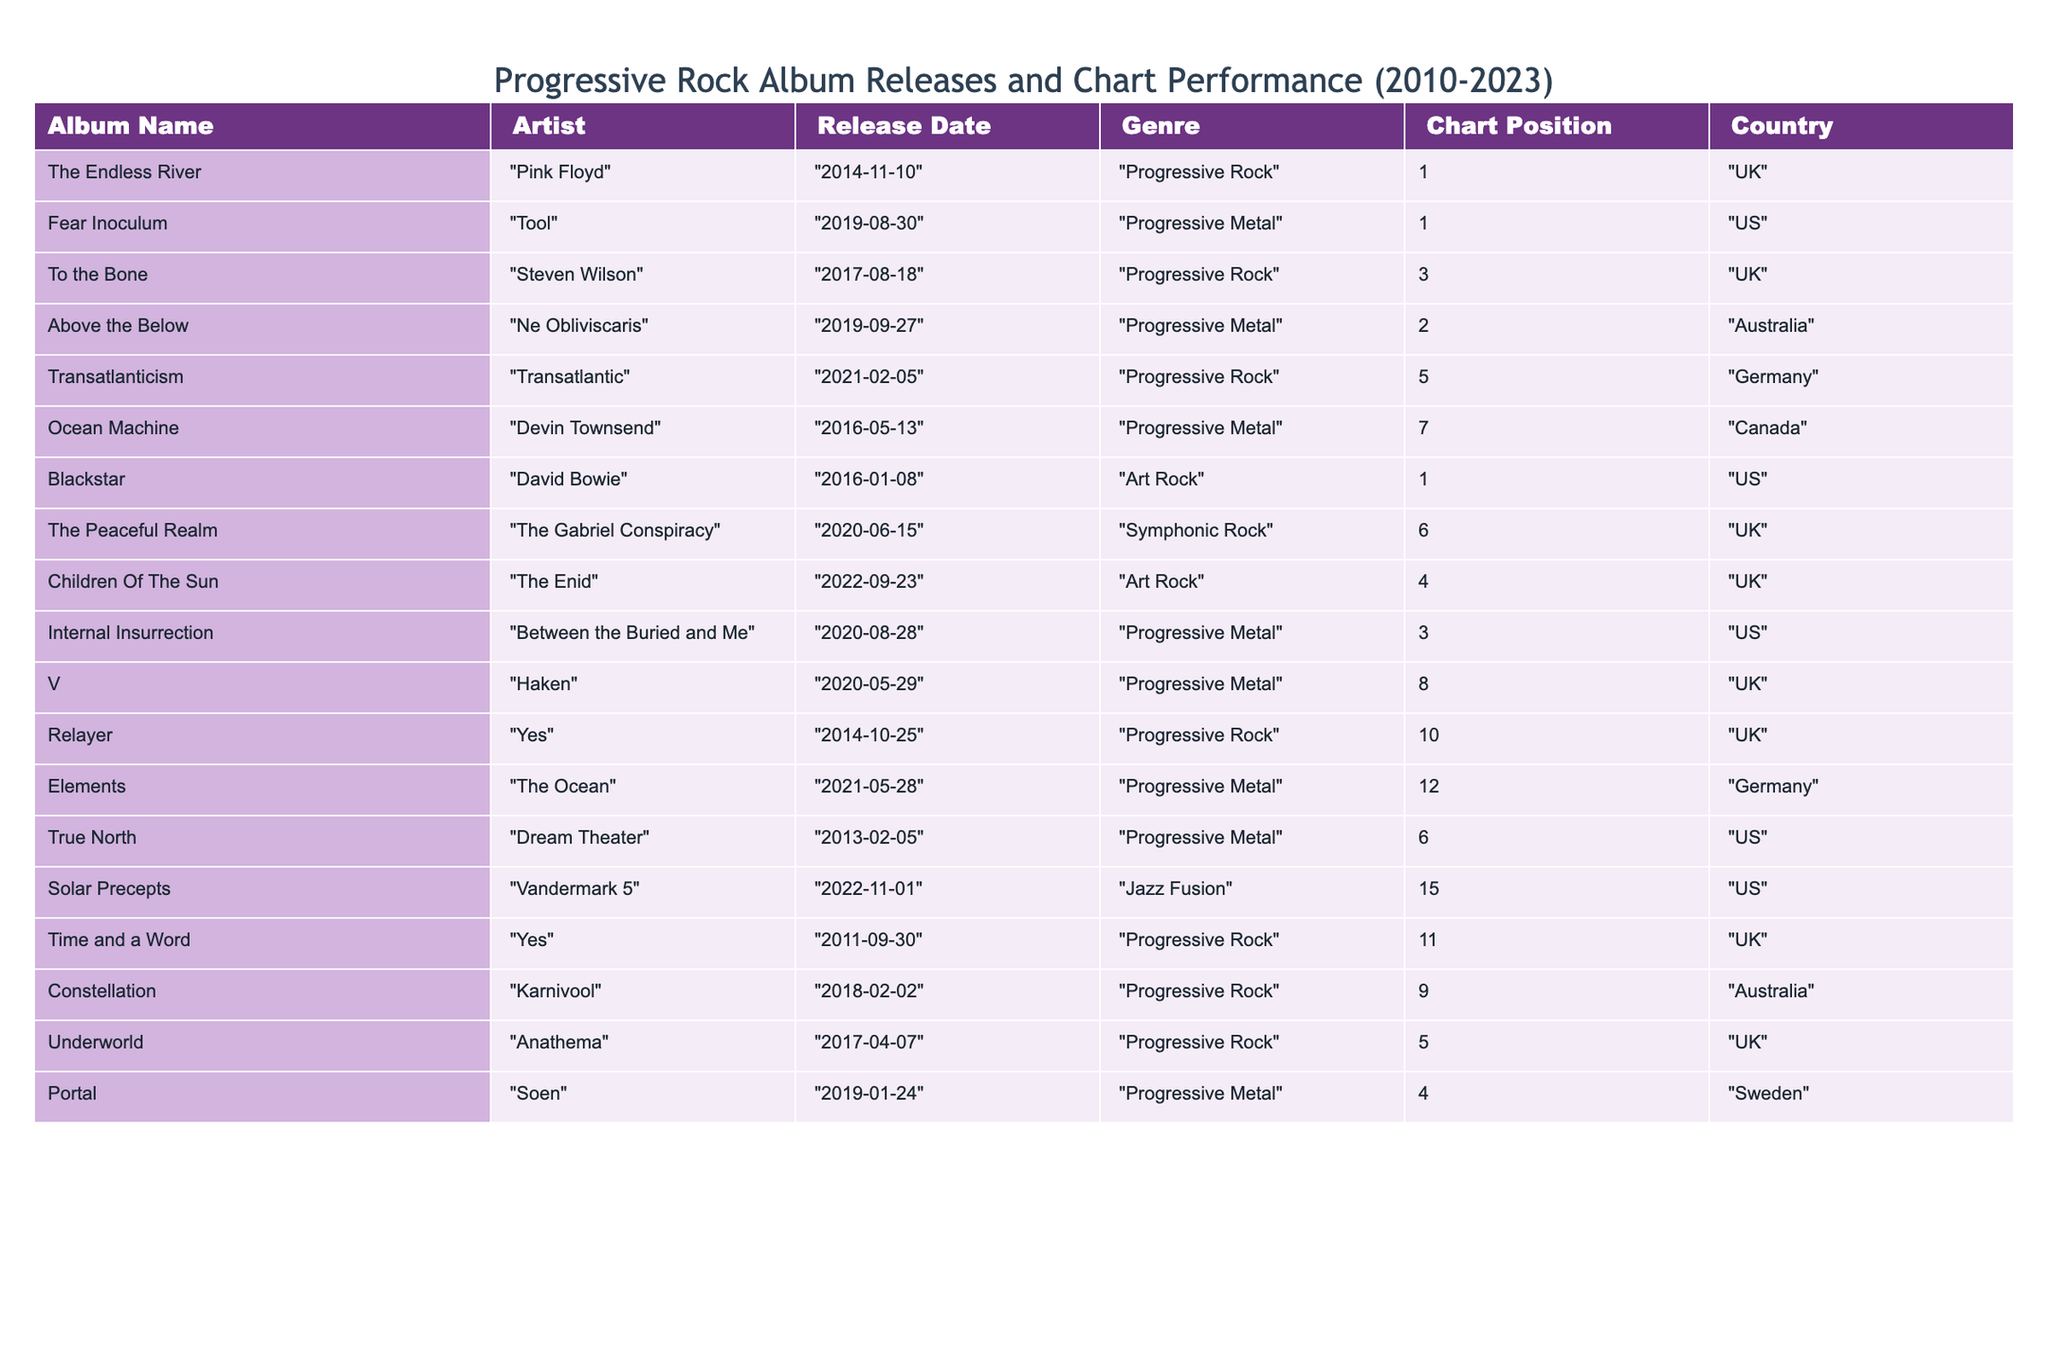What's the highest chart position achieved by a progressive rock album in this table? The table shows the "Chart Position" column for progressive rock albums. Scanning through, I see that "The Endless River" by Pink Floyd achieved a position of 1, which is the highest.
Answer: 1 Which artist released an album with a chart position of 8? By checking the table, "Haken" released the album "V," and it reached a chart position of 8.
Answer: Haken How many albums from the US are listed and what are their chart positions? Looking through the "Country" column, I find three albums from the US: "Fear Inoculum" (1), "Blackstar" (1), and "True North" (6). Summing their chart positions gives us 1 + 1 + 6 = 8.
Answer: 8 Which progressive metal album was released first and what was its chart position? The table lists "True North" by Dream Theater as released on "2013-02-05," which is earlier than the other metal albums. It reached chart position 6.
Answer: True North, 6 What is the average chart position of the albums by progressive rock bands in the UK? The UK has "The Endless River" (1), "To the Bone" (3), "The Peaceful Realm" (6), "Children Of The Sun" (4), "Relayer" (10), and "Underworld" (5). The total chart positions sum to 1 + 3 + 6 + 4 + 10 + 5 = 29, and there are 6 albums, giving an average of 29 / 6 = 4.83.
Answer: 4.83 Is there an album by Anathema listed in this table? Checking the artist column, I find "Underworld" by Anathema, confirming that the album is listed.
Answer: Yes What is the total number of albums in the table that fall under the genre of Progressive Metal? Counting the rows under the "Genre" column, I see there are five albums in the Progressive Metal category: “Fear Inoculum,” “Above the Below,” “Ocean Machine,” “Internal Insurrection,” and “Portal.” Thus, the total is 5.
Answer: 5 Was any album released by the band Yes after 2014? The table shows two listings for Yes: "Relayer" from 2014 and "Time and a Word" from 2011. Both were released before 2014, so the answer is no albums were released after 2014.
Answer: No Which artists had albums that achieved a top 5 chart position but were not released in the US? Reviewing the table, the artists with top 5 chart positions that are not from the US are Pink Floyd (1), Ne Obliviscaris (2), and Transatlantic (5).
Answer: Pink Floyd, Ne Obliviscaris, Transatlantic What is the difference between the highest chart position and the lowest chart position of albums in the table? The highest position reached is 1 (by multiple artists) and the lowest is 15 (by Vandermark 5). The difference is 15 - 1 = 14.
Answer: 14 